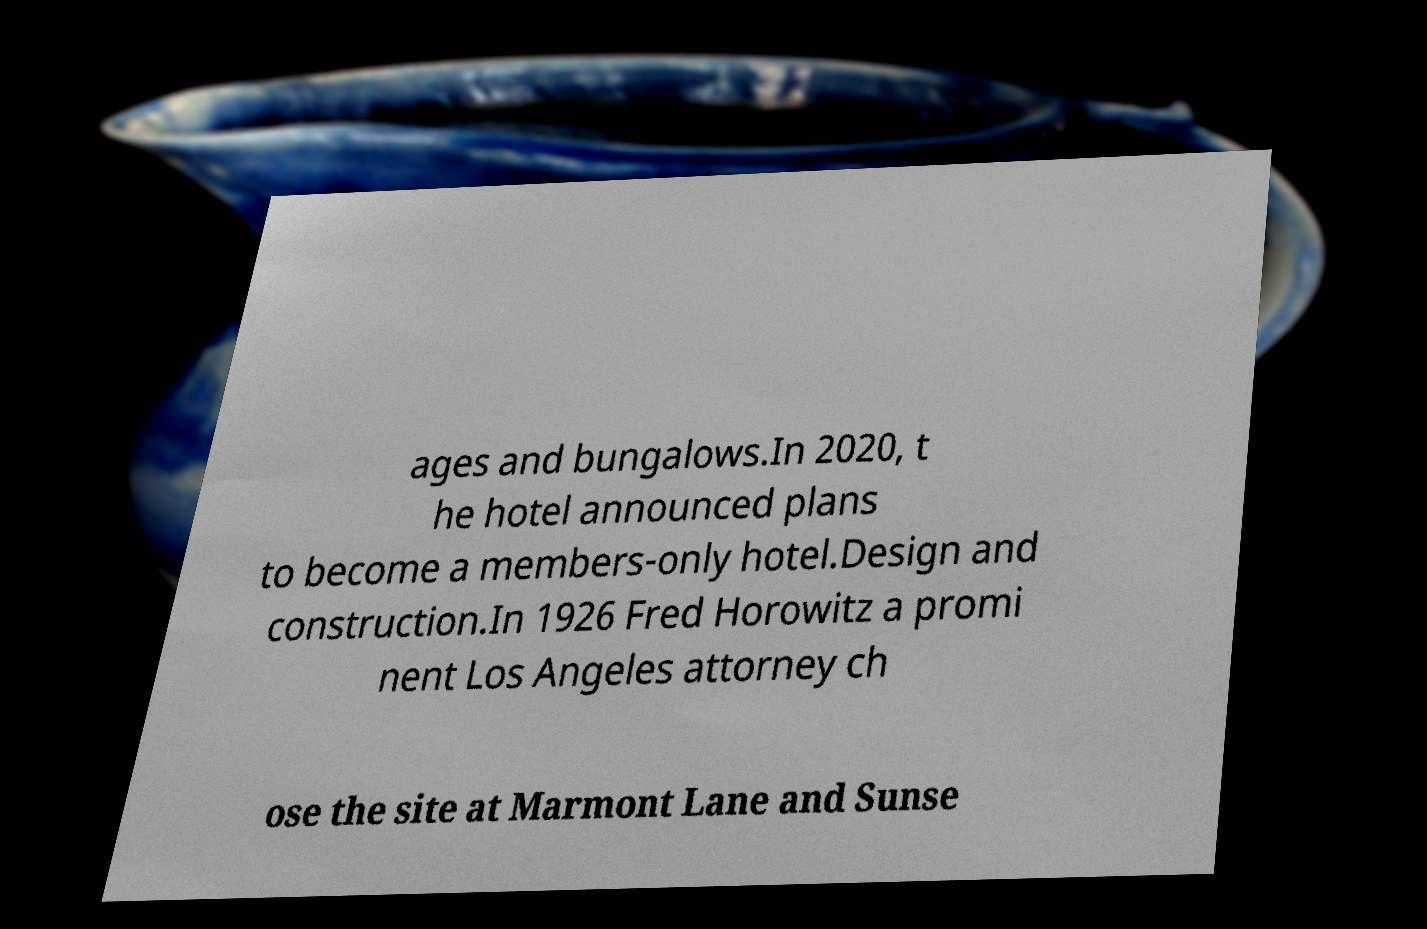Please identify and transcribe the text found in this image. ages and bungalows.In 2020, t he hotel announced plans to become a members-only hotel.Design and construction.In 1926 Fred Horowitz a promi nent Los Angeles attorney ch ose the site at Marmont Lane and Sunse 